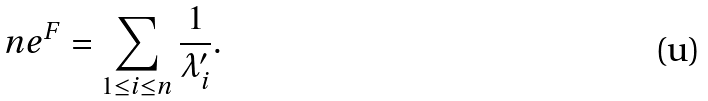Convert formula to latex. <formula><loc_0><loc_0><loc_500><loc_500>n e ^ { F } = \sum _ { 1 \leq i \leq n } \frac { 1 } { \lambda ^ { \prime } _ { i } } .</formula> 